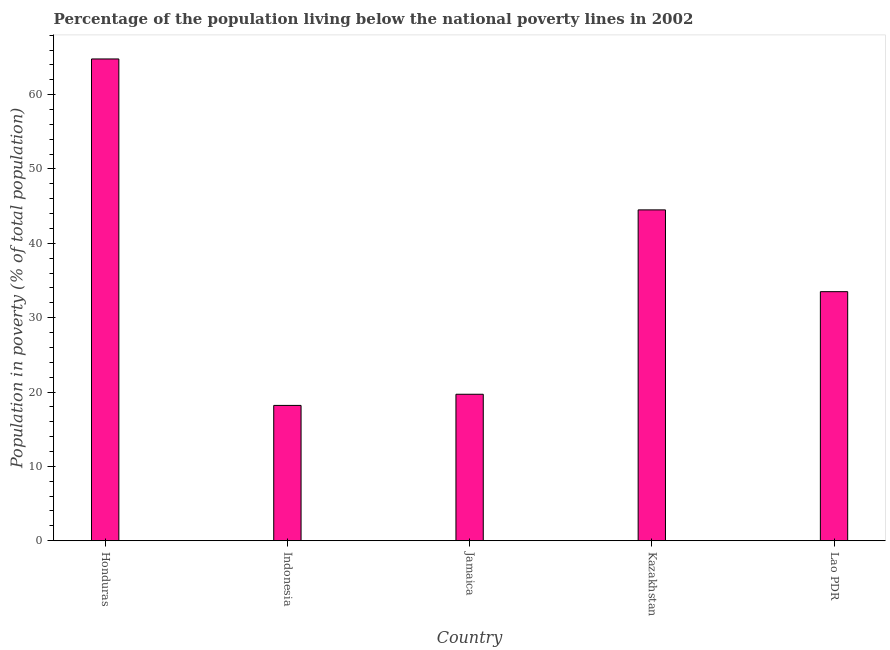Does the graph contain any zero values?
Provide a succinct answer. No. Does the graph contain grids?
Your answer should be very brief. No. What is the title of the graph?
Offer a very short reply. Percentage of the population living below the national poverty lines in 2002. What is the label or title of the Y-axis?
Your answer should be compact. Population in poverty (% of total population). Across all countries, what is the maximum percentage of population living below poverty line?
Ensure brevity in your answer.  64.8. In which country was the percentage of population living below poverty line maximum?
Your response must be concise. Honduras. What is the sum of the percentage of population living below poverty line?
Your answer should be compact. 180.7. What is the difference between the percentage of population living below poverty line in Kazakhstan and Lao PDR?
Your answer should be very brief. 11. What is the average percentage of population living below poverty line per country?
Your response must be concise. 36.14. What is the median percentage of population living below poverty line?
Your answer should be very brief. 33.5. What is the ratio of the percentage of population living below poverty line in Indonesia to that in Jamaica?
Provide a short and direct response. 0.92. Is the percentage of population living below poverty line in Honduras less than that in Jamaica?
Your answer should be compact. No. Is the difference between the percentage of population living below poverty line in Honduras and Indonesia greater than the difference between any two countries?
Provide a short and direct response. Yes. What is the difference between the highest and the second highest percentage of population living below poverty line?
Keep it short and to the point. 20.3. What is the difference between the highest and the lowest percentage of population living below poverty line?
Keep it short and to the point. 46.6. In how many countries, is the percentage of population living below poverty line greater than the average percentage of population living below poverty line taken over all countries?
Ensure brevity in your answer.  2. How many countries are there in the graph?
Your response must be concise. 5. Are the values on the major ticks of Y-axis written in scientific E-notation?
Your response must be concise. No. What is the Population in poverty (% of total population) in Honduras?
Your answer should be very brief. 64.8. What is the Population in poverty (% of total population) in Kazakhstan?
Provide a succinct answer. 44.5. What is the Population in poverty (% of total population) of Lao PDR?
Offer a terse response. 33.5. What is the difference between the Population in poverty (% of total population) in Honduras and Indonesia?
Provide a succinct answer. 46.6. What is the difference between the Population in poverty (% of total population) in Honduras and Jamaica?
Offer a terse response. 45.1. What is the difference between the Population in poverty (% of total population) in Honduras and Kazakhstan?
Give a very brief answer. 20.3. What is the difference between the Population in poverty (% of total population) in Honduras and Lao PDR?
Provide a short and direct response. 31.3. What is the difference between the Population in poverty (% of total population) in Indonesia and Kazakhstan?
Your answer should be compact. -26.3. What is the difference between the Population in poverty (% of total population) in Indonesia and Lao PDR?
Provide a short and direct response. -15.3. What is the difference between the Population in poverty (% of total population) in Jamaica and Kazakhstan?
Make the answer very short. -24.8. What is the difference between the Population in poverty (% of total population) in Jamaica and Lao PDR?
Offer a very short reply. -13.8. What is the difference between the Population in poverty (% of total population) in Kazakhstan and Lao PDR?
Give a very brief answer. 11. What is the ratio of the Population in poverty (% of total population) in Honduras to that in Indonesia?
Your answer should be very brief. 3.56. What is the ratio of the Population in poverty (% of total population) in Honduras to that in Jamaica?
Your response must be concise. 3.29. What is the ratio of the Population in poverty (% of total population) in Honduras to that in Kazakhstan?
Provide a succinct answer. 1.46. What is the ratio of the Population in poverty (% of total population) in Honduras to that in Lao PDR?
Make the answer very short. 1.93. What is the ratio of the Population in poverty (% of total population) in Indonesia to that in Jamaica?
Your answer should be compact. 0.92. What is the ratio of the Population in poverty (% of total population) in Indonesia to that in Kazakhstan?
Give a very brief answer. 0.41. What is the ratio of the Population in poverty (% of total population) in Indonesia to that in Lao PDR?
Your answer should be compact. 0.54. What is the ratio of the Population in poverty (% of total population) in Jamaica to that in Kazakhstan?
Ensure brevity in your answer.  0.44. What is the ratio of the Population in poverty (% of total population) in Jamaica to that in Lao PDR?
Offer a very short reply. 0.59. What is the ratio of the Population in poverty (% of total population) in Kazakhstan to that in Lao PDR?
Provide a short and direct response. 1.33. 